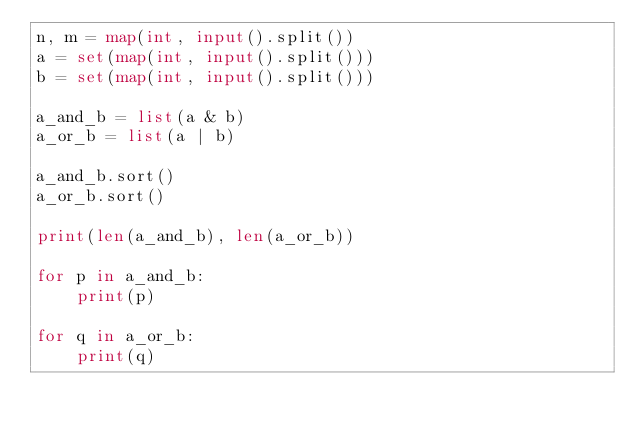<code> <loc_0><loc_0><loc_500><loc_500><_Python_>n, m = map(int, input().split())
a = set(map(int, input().split()))
b = set(map(int, input().split()))

a_and_b = list(a & b)
a_or_b = list(a | b)

a_and_b.sort()
a_or_b.sort()

print(len(a_and_b), len(a_or_b))

for p in a_and_b:
    print(p)

for q in a_or_b:
    print(q)

</code> 